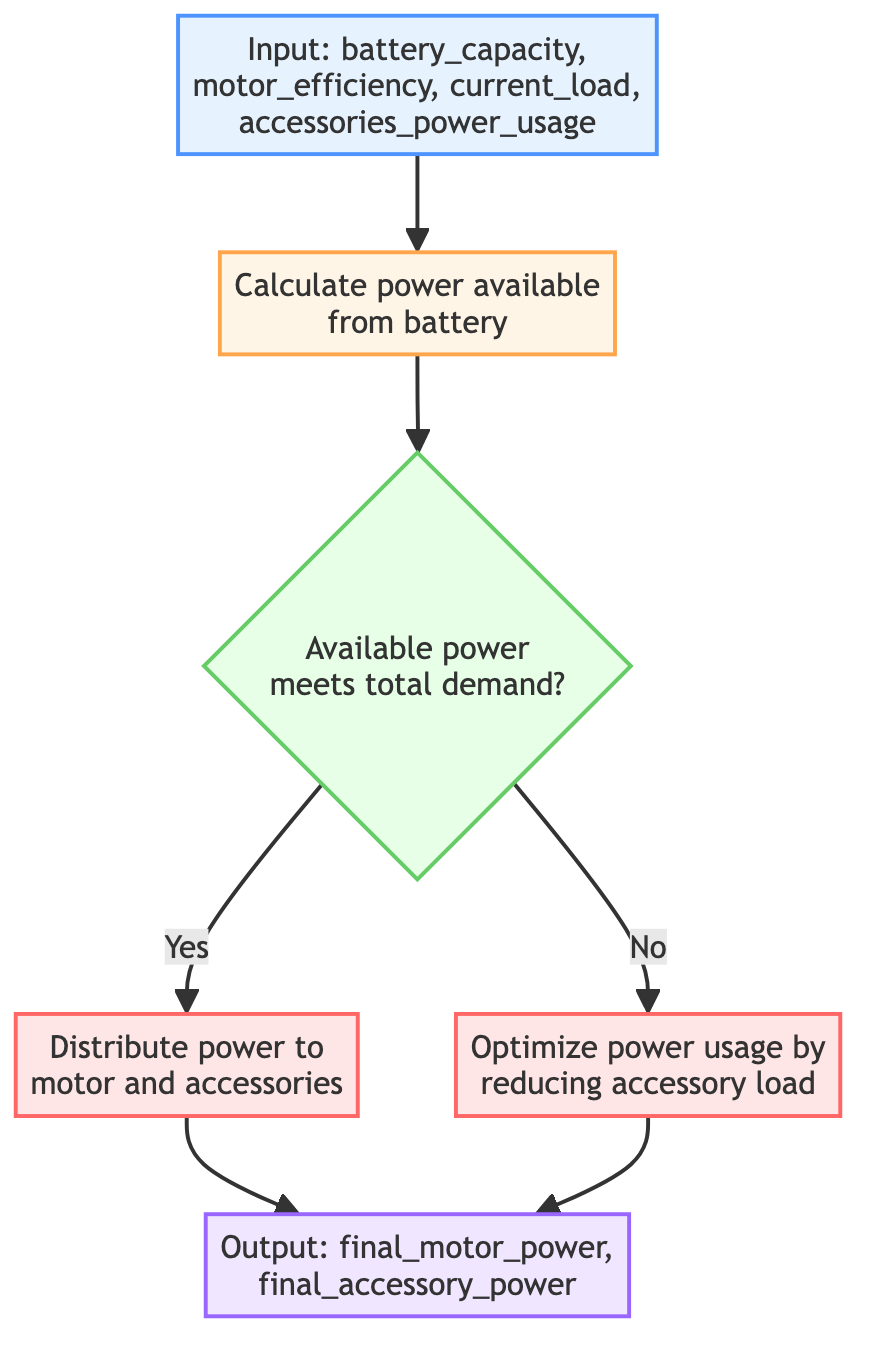What are the input parameters to the function? The input parameters listed in the diagram are battery_capacity, motor_efficiency, current_load, and accessories_power_usage.
Answer: battery_capacity, motor_efficiency, current_load, accessories_power_usage What is the output of the function? The output parameters from the flowchart are final_motor_power and final_accessory_power.
Answer: final_motor_power, final_accessory_power What does Step 1 calculate? Step 1 is labeled "Calculate power available from battery," which indicates it computes the power that can be extracted from the battery.
Answer: power available from battery What happens if the available power does not meet the total demand? If the available power does not meet the total demand, the diagram directs the flow to Step 4, which optimizes power usage by reducing accessory load.
Answer: Optimize power usage by reducing accessory load What action is taken in Step 3? Step 3 involves distributing power to the motor and accessories based on the available power and demand.
Answer: Distribute power to motor and accessories What decision point is present in the flowchart? The decision point is whether the available power meets the total demand, which is a critical condition in the flow.
Answer: Available power meets total demand? What is the flow of action if the available power is sufficient? If available power is sufficient, the flow continues to Step 3, where power is distributed to the motor and accessories.
Answer: Distribute power to motor and accessories How many steps are there in this flowchart? The flowchart contains a total of five steps: one calculation (Step 1), one decision (Step 2), and two actions (Steps 3 and 4) before producing output.
Answer: five steps What type of flowchart is shown? This flowchart is a specific type that represents a Python function with a defined sequence of parameters, calculations, decisions, and actions.
Answer: flowchart of a Python Function 